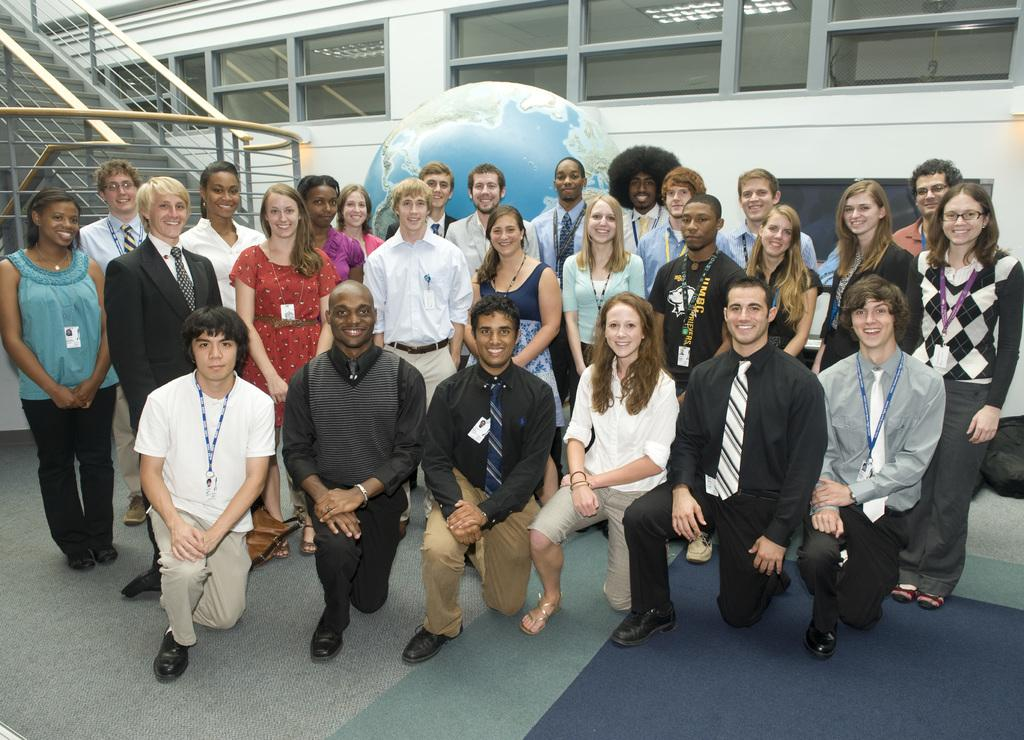How many people are in the image? There is a group of people in the image, but the exact number is not specified. What is the facial expression of the people in the image? The people in the image are smiling. What positions are the people in the image adopting? Some people are standing, while others are kneeling on the floor. What can be seen in the background of the image? There is a wall, glass windows, railings, and stairs in the background of the image. What type of ball is being used by the tiger in the image? There is no tiger or ball present in the image. 